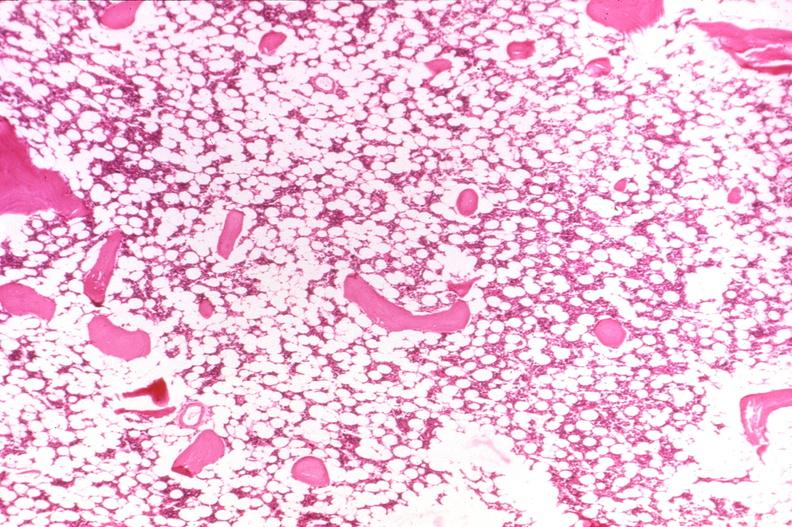what does this image show?
Answer the question using a single word or phrase. Bone 